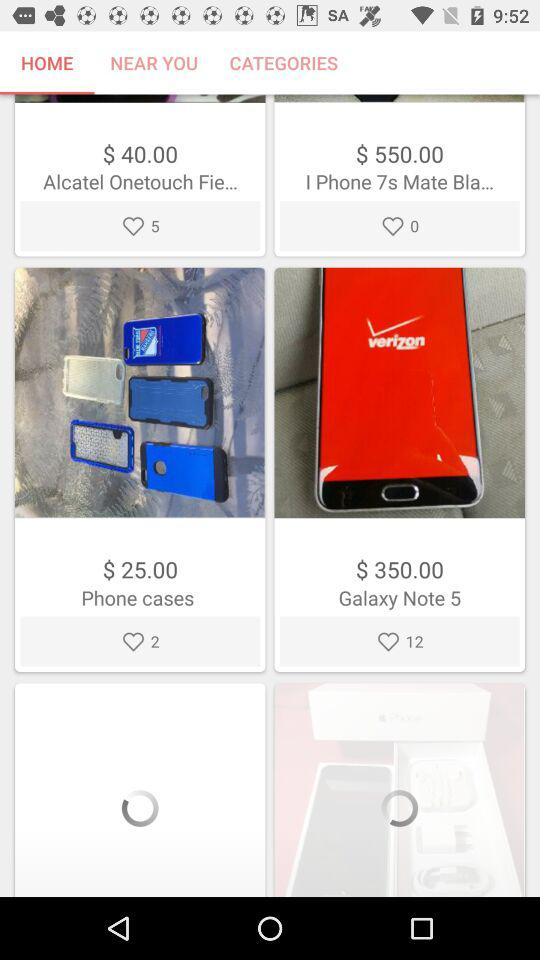What is the cost of "Galaxy Note 5"?
Answer the question using a single word or phrase. It costs $350. 